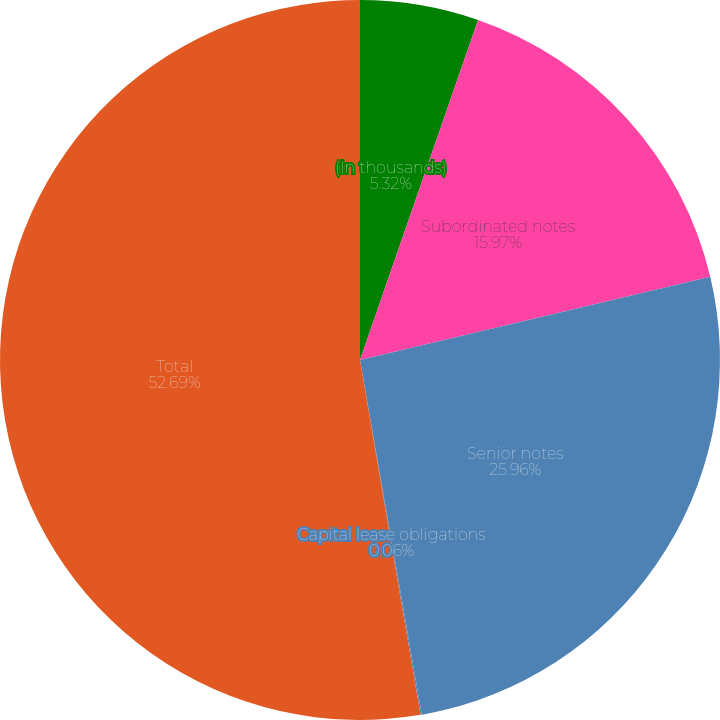Convert chart to OTSL. <chart><loc_0><loc_0><loc_500><loc_500><pie_chart><fcel>(In thousands)<fcel>Subordinated notes<fcel>Senior notes<fcel>Capital lease obligations<fcel>Total<nl><fcel>5.32%<fcel>15.97%<fcel>25.96%<fcel>0.06%<fcel>52.69%<nl></chart> 